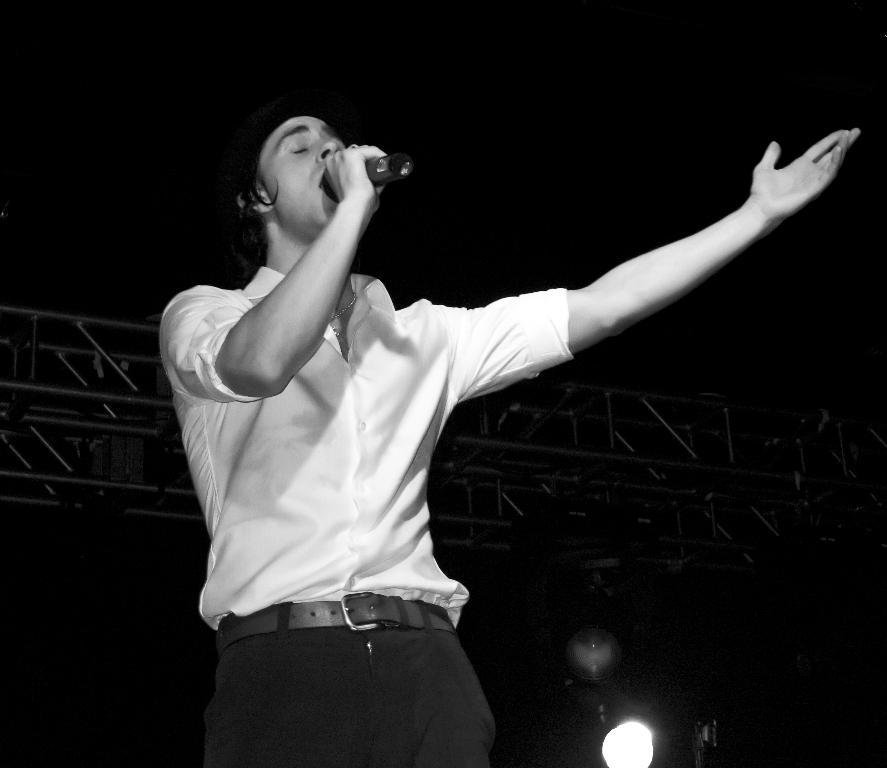What is the color scheme of the image? The image is black and white. Who is the main subject in the image? There is a man in the image. What is the man doing in the image? The man is singing. What object is the man holding in the image? The man is holding a microphone (mike). Can you describe the lighting in the image? There is light in the image. What is the weight of the crow in the image? There is no crow present in the image. What is the range of the man's voice in the image? The image does not provide information about the range of the man's voice. 